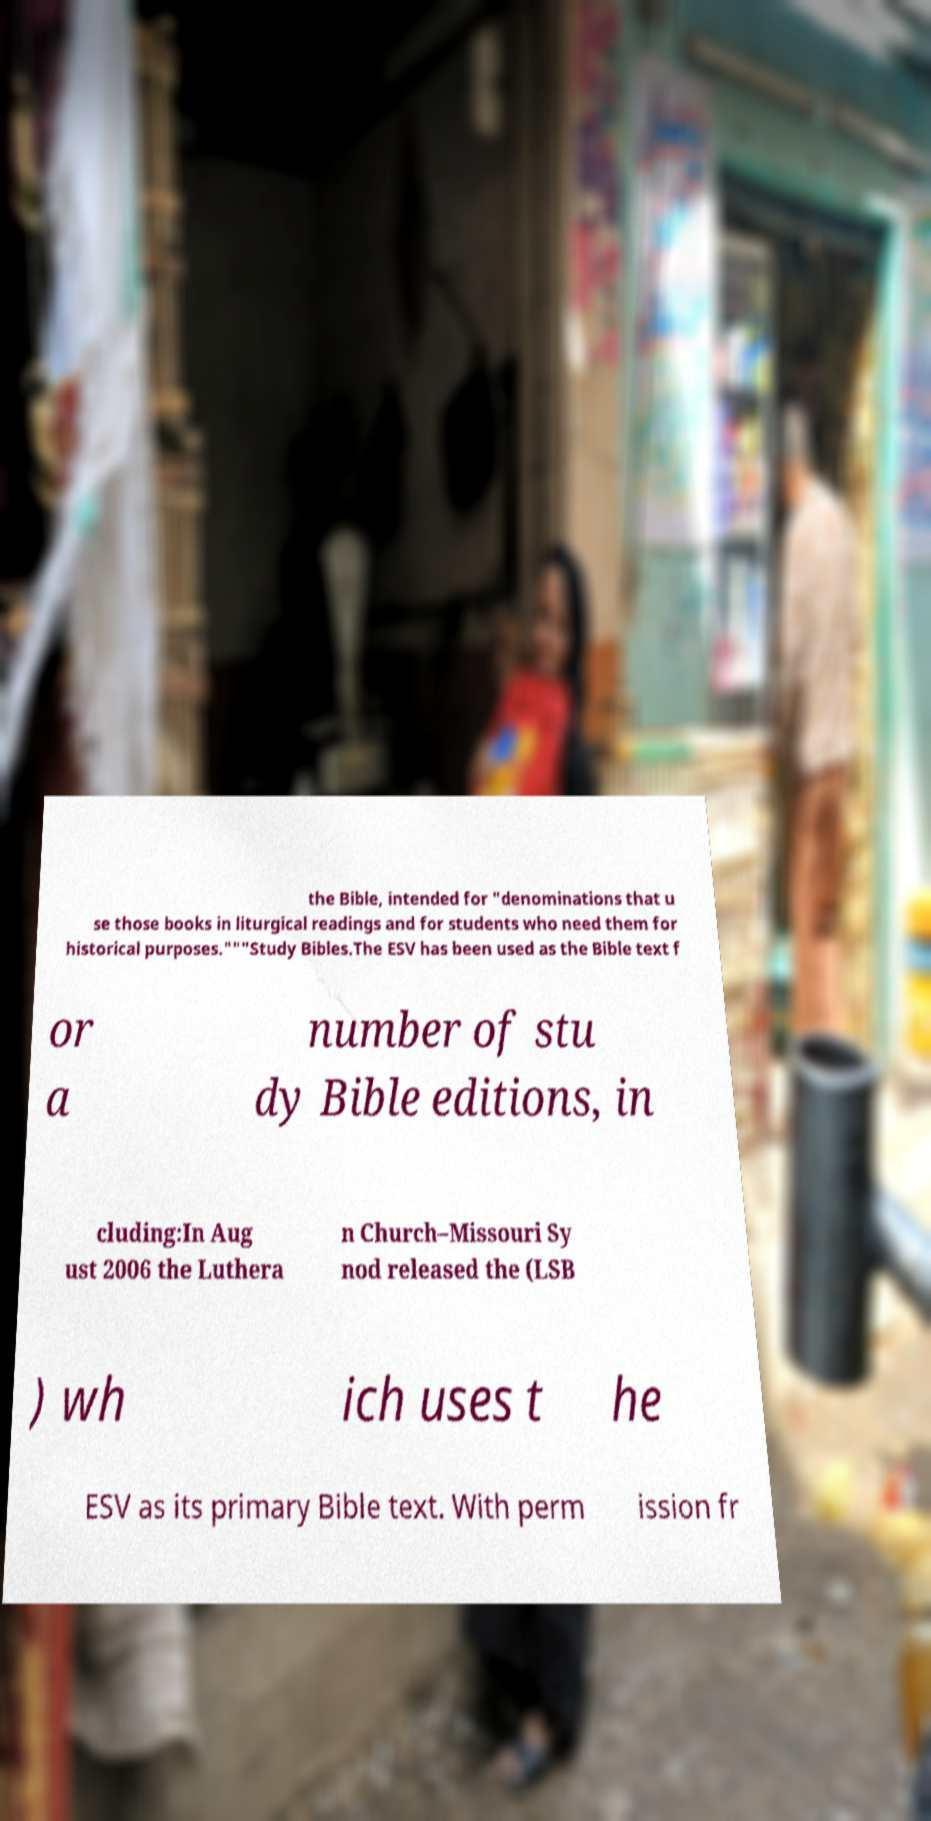Please identify and transcribe the text found in this image. the Bible, intended for "denominations that u se those books in liturgical readings and for students who need them for historical purposes."""Study Bibles.The ESV has been used as the Bible text f or a number of stu dy Bible editions, in cluding:In Aug ust 2006 the Luthera n Church–Missouri Sy nod released the (LSB ) wh ich uses t he ESV as its primary Bible text. With perm ission fr 